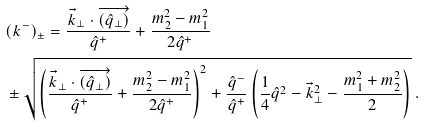Convert formula to latex. <formula><loc_0><loc_0><loc_500><loc_500>& ( k ^ { - } ) _ { \pm } = \frac { \vec { k } _ { \perp } \cdot \overrightarrow { ( \hat { q } _ { \perp } ) } } { \hat { q } ^ { + } } + \frac { m _ { 2 } ^ { 2 } - m _ { 1 } ^ { 2 } } { 2 \hat { q } ^ { + } } \\ & \pm \sqrt { \left ( \frac { \vec { k } _ { \perp } \cdot \overrightarrow { ( \hat { q } _ { \perp } ) } } { \hat { q } ^ { + } } + \frac { m _ { 2 } ^ { 2 } - m _ { 1 } ^ { 2 } } { 2 \hat { q } ^ { + } } \right ) ^ { 2 } + \frac { \hat { q } ^ { - } } { \hat { q } ^ { + } } \left ( \frac { 1 } { 4 } \hat { q } ^ { 2 } - \vec { k } _ { \perp } ^ { 2 } - \frac { m _ { 1 } ^ { 2 } + m _ { 2 } ^ { 2 } } { 2 } \right ) } \ .</formula> 